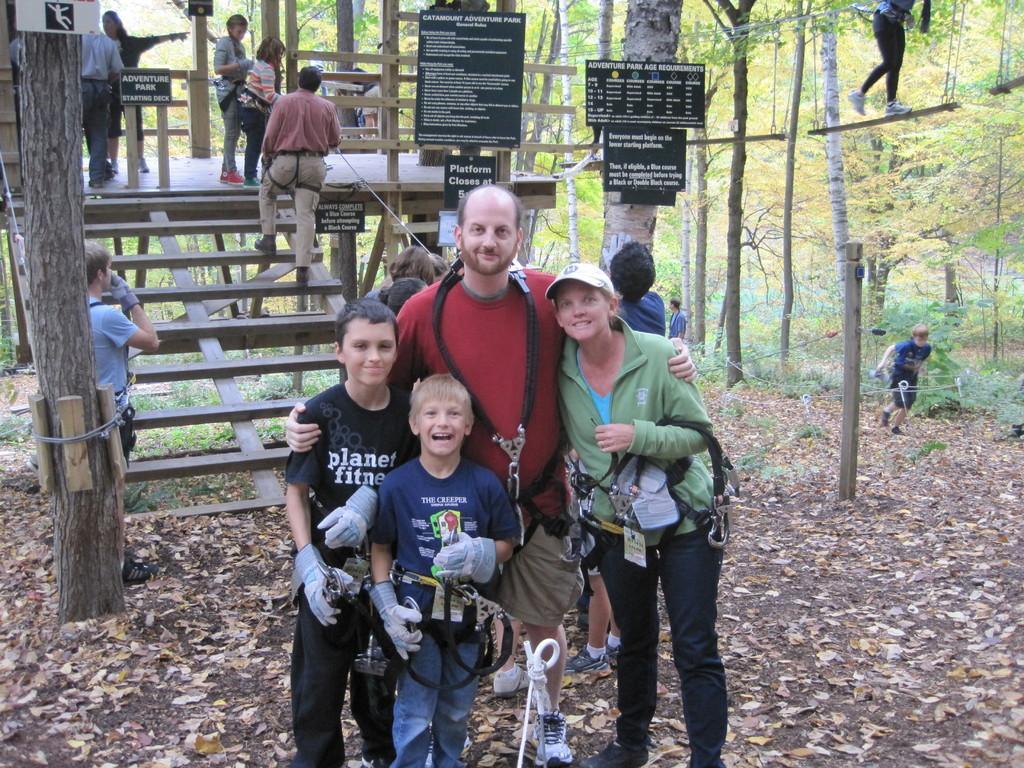In one or two sentences, can you explain what this image depicts? In the center of the image we can see four people are standing and they are smiling and they are in different costumes. And we can see they are wearing some objects. Among them, we can see one person is wearing a cap. In the background, we can see trees, sign boards, plants, dry leaves, fences, few people are standing, few people are holding some objects, staircase and a few other objects. At the top right side of the image, we can see one person is walking on the wooden object, which is attached to the rope. 